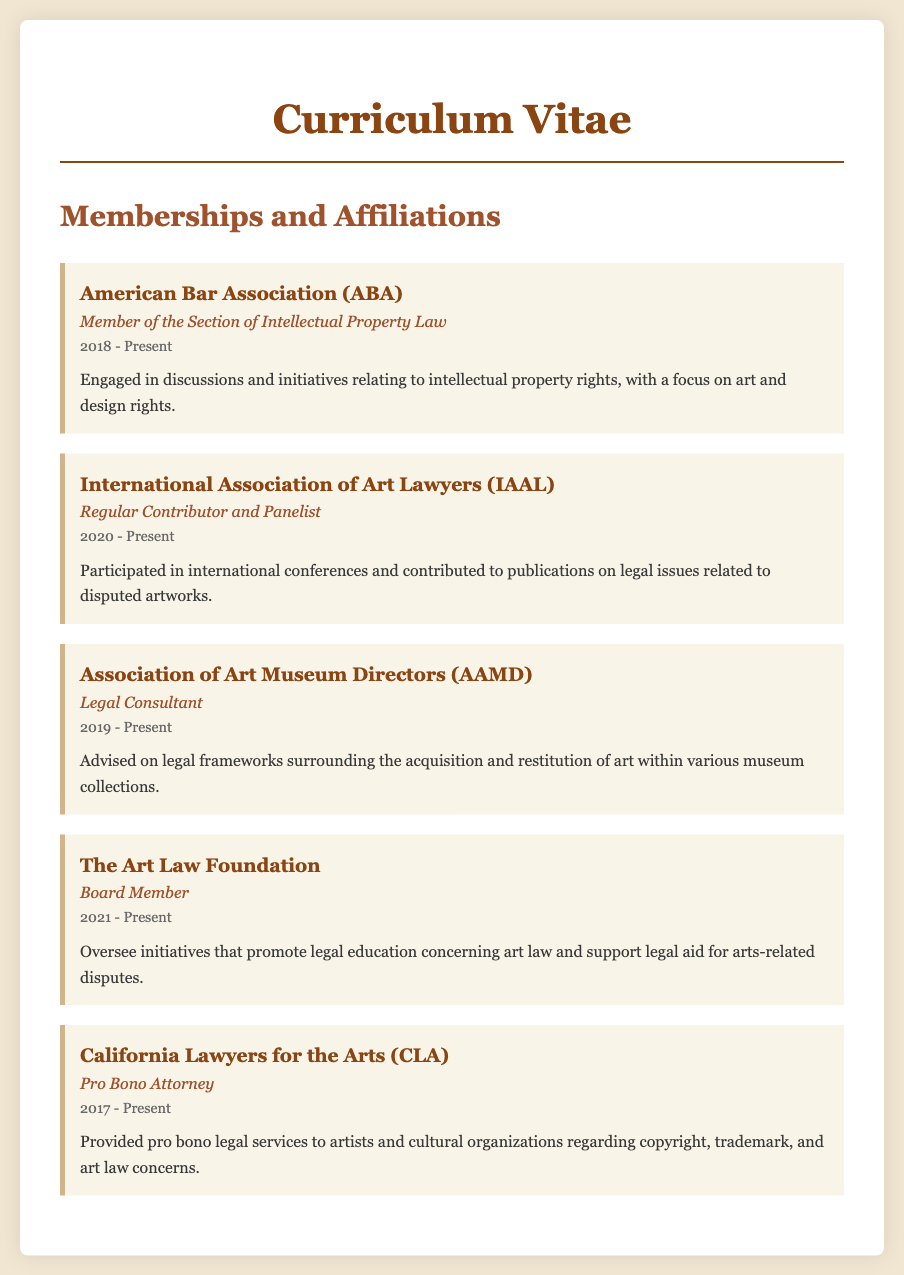What is the name of the first organization listed? The first organization listed in the document is the American Bar Association.
Answer: American Bar Association What is the role held at the International Association of Art Lawyers? The role held at the International Association of Art Lawyers is Regular Contributor and Panelist.
Answer: Regular Contributor and Panelist In which year did the member start their affiliation with the Association of Art Museum Directors? The member started their affiliation with the Association of Art Museum Directors in 2019.
Answer: 2019 How long has the individual been a Pro Bono Attorney at California Lawyers for the Arts? The individual has been a Pro Bono Attorney at California Lawyers for the Arts since 2017, so they have been in this role for approximately 6 years.
Answer: 6 years Which organization focuses on legal education concerning art law? The organization that focuses on legal education concerning art law is The Art Law Foundation.
Answer: The Art Law Foundation What is a key topic discussed within the American Bar Association's section that the member is involved in? A key topic discussed within the American Bar Association's section is intellectual property rights.
Answer: intellectual property rights Which year marks the beginning of the member's involvement with The Art Law Foundation? The year that marks the beginning of the member's involvement with The Art Law Foundation is 2021.
Answer: 2021 What type of legal services does the member provide to artists through California Lawyers for the Arts? The member provides pro bono legal services regarding copyright, trademark, and art law concerns.
Answer: pro bono legal services regarding copyright, trademark, and art law concerns How many years has the member been affiliated with the International Association of Art Lawyers as of 2023? As of 2023, the member has been affiliated with the International Association of Art Lawyers for 3 years.
Answer: 3 years 